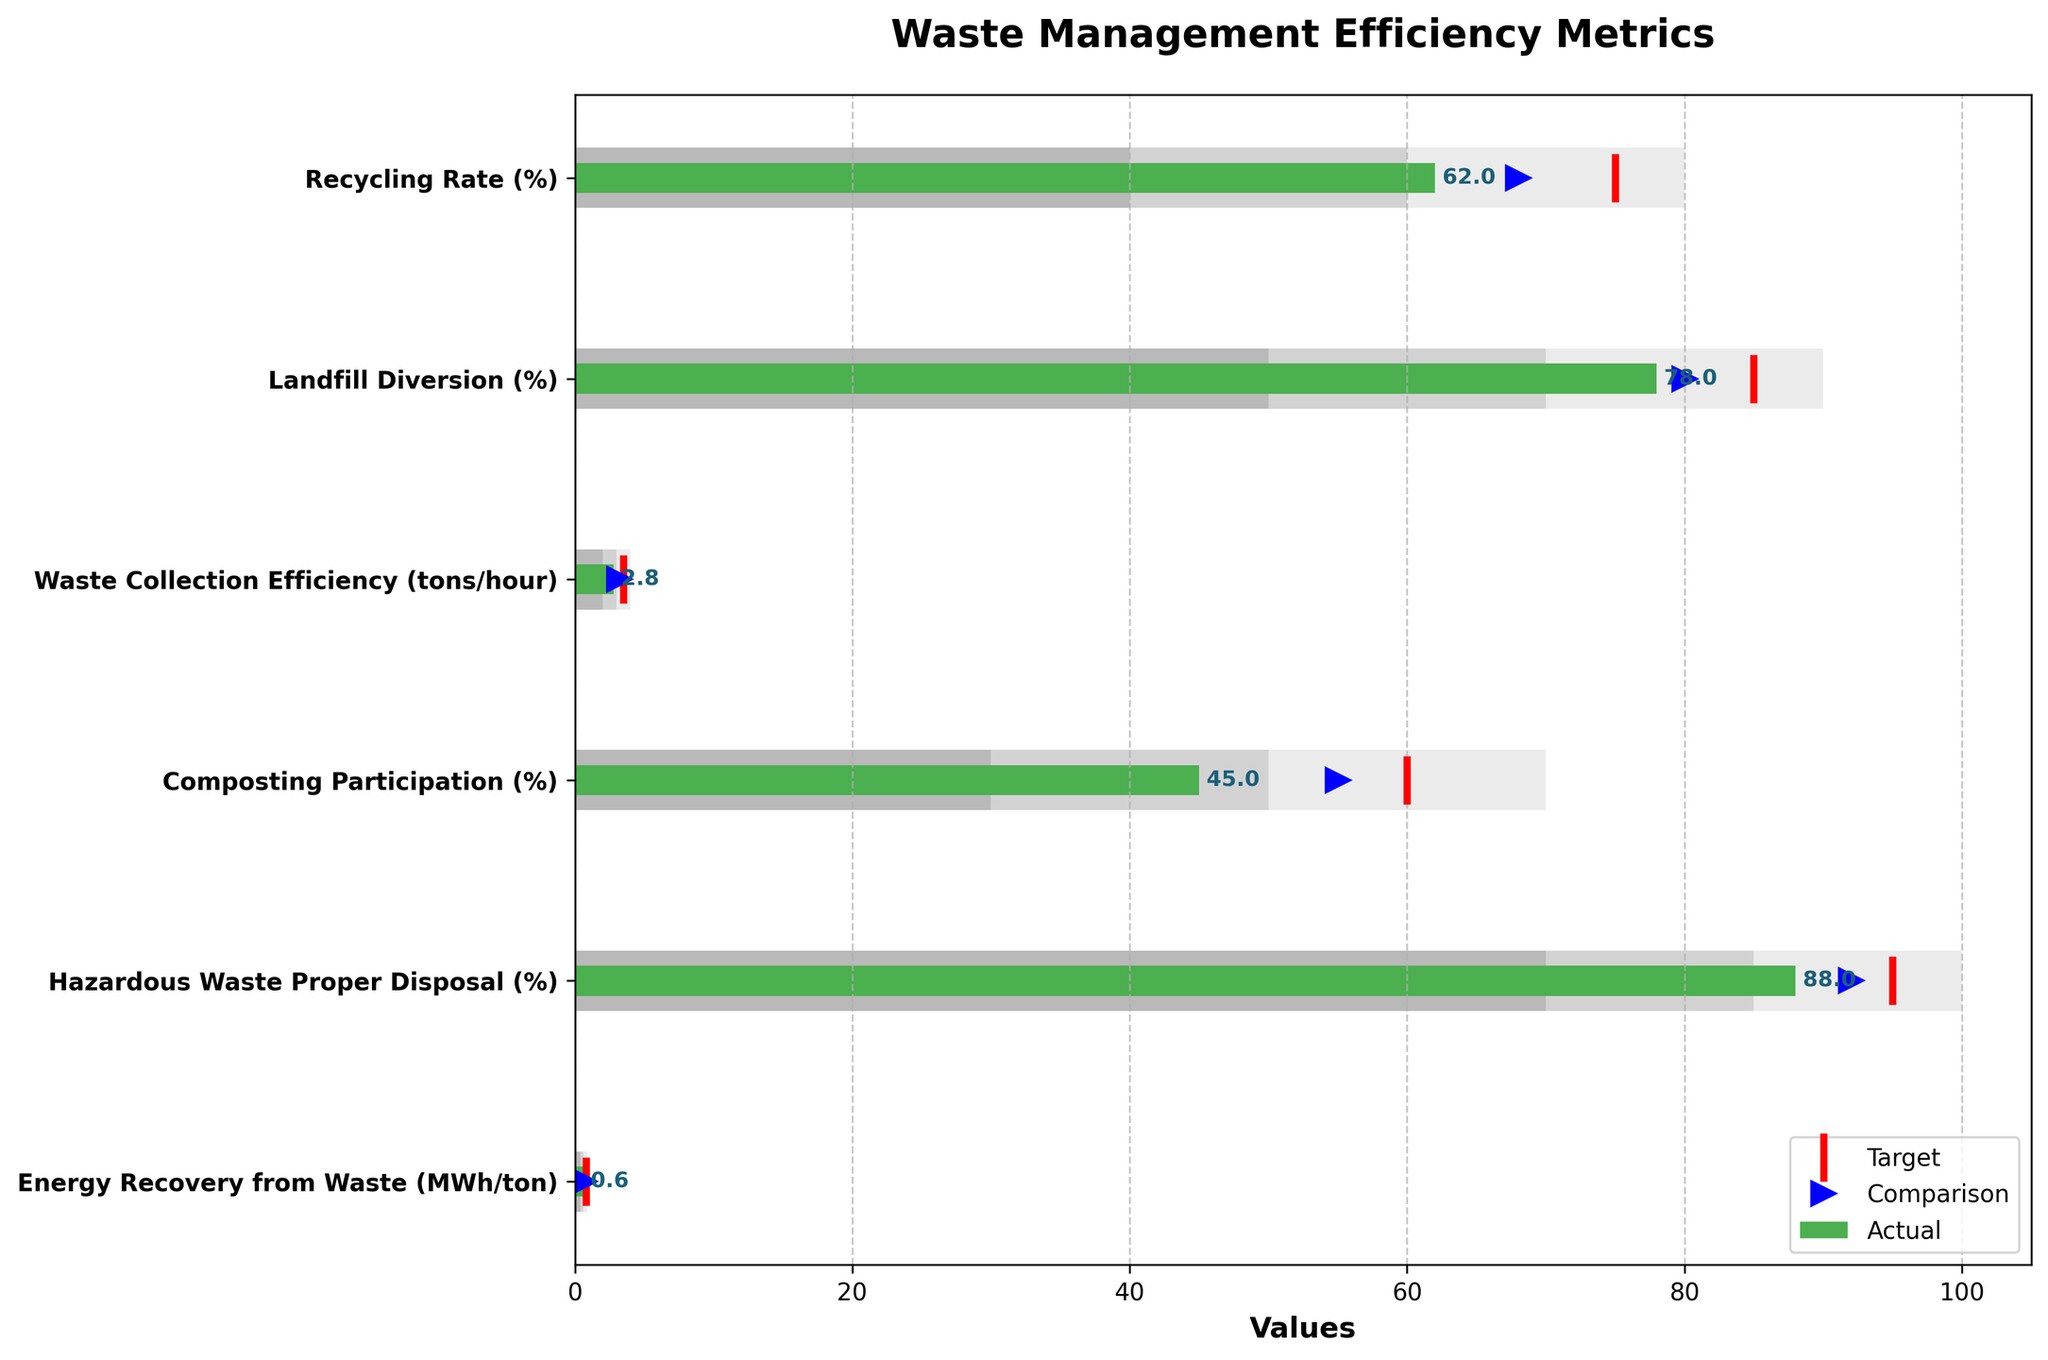What's the title of the figure? The title is typically located at the top of the figure, in this case, it reads "Waste Management Efficiency Metrics".
Answer: Waste Management Efficiency Metrics How many metrics are displayed in the figure? Count the number of different titles listed along the y-axis. In this figure, there are six metrics.
Answer: Six Which metric has the highest target value? Look at the "Target" values for each metric. The highest target value is for "Hazardous Waste Proper Disposal (%)" with a target of 95.
Answer: Hazardous Waste Proper Disposal (%) What's the difference between the actual and target values for the Recycling Rate (%)? Subtract the actual value for Recycling Rate (%) from its target value: 75 - 62 = 13.
Answer: 13 Which metric comes closest to meeting its target value? Determine the absolute difference between actual and target values for each metric, and find the smallest difference. For "Energy Recovery from Waste (MWh/ton)", the difference is 0.8 - 0.6 = 0.2.
Answer: Energy Recovery from Waste (MWh/ton) Is the Landfill Diversion (%) performance above, below, or at the comparison mark? Compare the actual value (78%) with the comparison mark (80%). The actual value is below the comparison mark.
Answer: Below What range does the Recycling Rate (%) fall into? Look at the bars indicating ranges and see where the actual value of 62% fits. It falls in "Range 2" (40-60%) and slightly into "Range 3" (60-80%).
Answer: Range 2 and 3 What's the range of the Waste Collection Efficiency (tons/hour)? Identify the "Range3" values, which set the max limits. For Waste Collection Efficiency, it's 2-4 tons/hour.
Answer: 2-4 tons/hour Is the Composting Participation (%) within its expected target range? Check if the actual value (45%) is within the target range values (30-70%).
Answer: Yes Which metric has the largest gap between actual and comparison values? Subtract the actual values from their corresponding comparison values and find the largest difference. For Waste Collection Efficiency (tons/hour), the gap is 3.2 - 2.8 = 0.4.
Answer: Waste Collection Efficiency (tons/hour) 